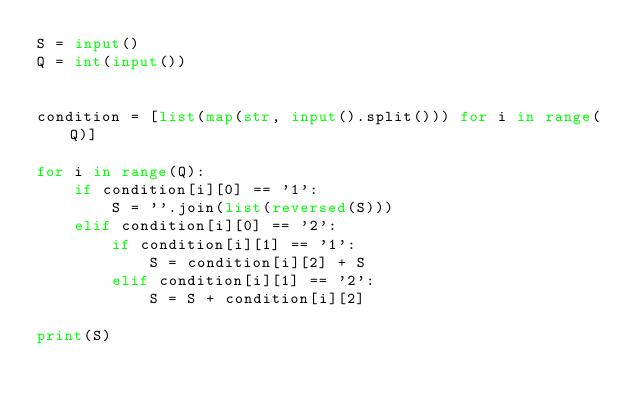<code> <loc_0><loc_0><loc_500><loc_500><_Python_>S = input()
Q = int(input())


condition = [list(map(str, input().split())) for i in range(Q)]

for i in range(Q):
    if condition[i][0] == '1':
        S = ''.join(list(reversed(S)))
    elif condition[i][0] == '2':
        if condition[i][1] == '1':
            S = condition[i][2] + S
        elif condition[i][1] == '2':
            S = S + condition[i][2]

print(S)
</code> 